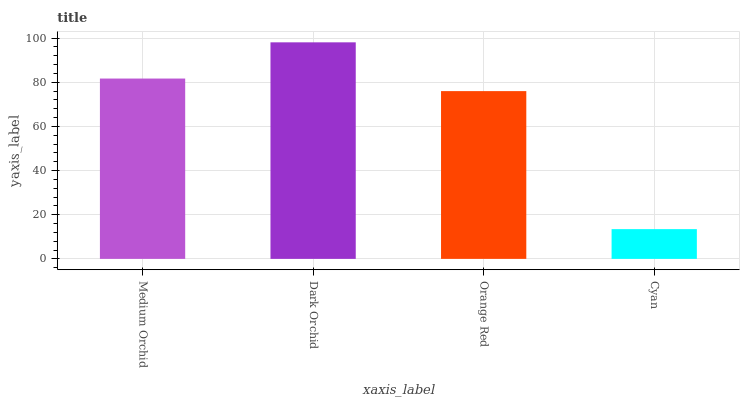Is Cyan the minimum?
Answer yes or no. Yes. Is Dark Orchid the maximum?
Answer yes or no. Yes. Is Orange Red the minimum?
Answer yes or no. No. Is Orange Red the maximum?
Answer yes or no. No. Is Dark Orchid greater than Orange Red?
Answer yes or no. Yes. Is Orange Red less than Dark Orchid?
Answer yes or no. Yes. Is Orange Red greater than Dark Orchid?
Answer yes or no. No. Is Dark Orchid less than Orange Red?
Answer yes or no. No. Is Medium Orchid the high median?
Answer yes or no. Yes. Is Orange Red the low median?
Answer yes or no. Yes. Is Dark Orchid the high median?
Answer yes or no. No. Is Dark Orchid the low median?
Answer yes or no. No. 